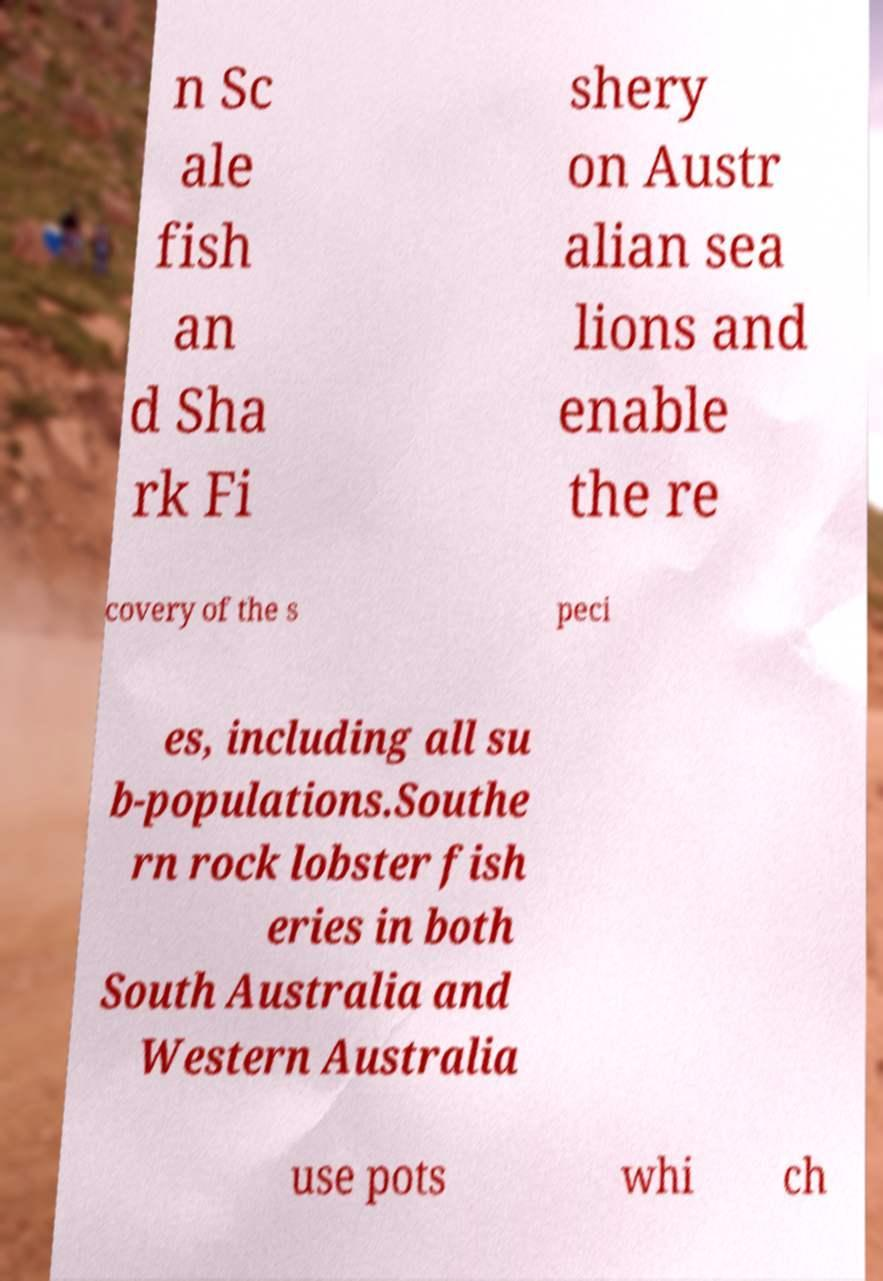Can you read and provide the text displayed in the image?This photo seems to have some interesting text. Can you extract and type it out for me? n Sc ale fish an d Sha rk Fi shery on Austr alian sea lions and enable the re covery of the s peci es, including all su b-populations.Southe rn rock lobster fish eries in both South Australia and Western Australia use pots whi ch 